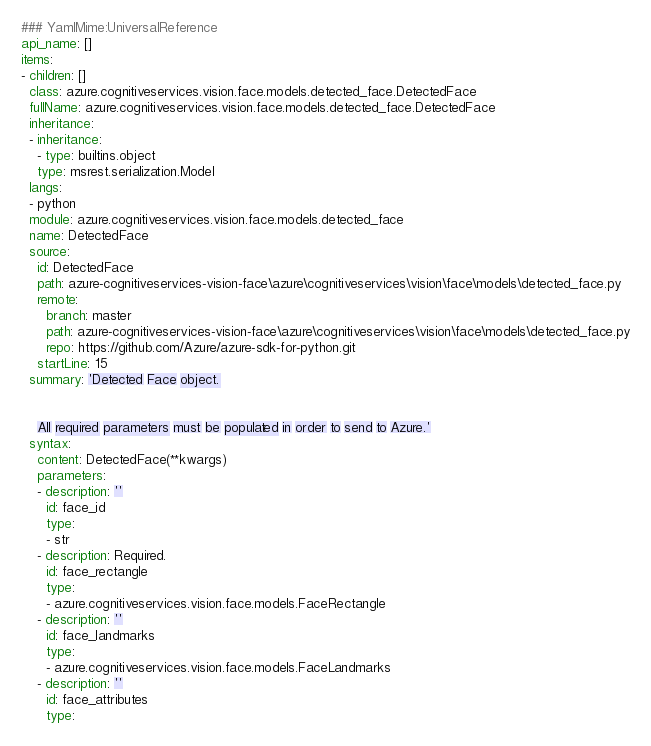<code> <loc_0><loc_0><loc_500><loc_500><_YAML_>### YamlMime:UniversalReference
api_name: []
items:
- children: []
  class: azure.cognitiveservices.vision.face.models.detected_face.DetectedFace
  fullName: azure.cognitiveservices.vision.face.models.detected_face.DetectedFace
  inheritance:
  - inheritance:
    - type: builtins.object
    type: msrest.serialization.Model
  langs:
  - python
  module: azure.cognitiveservices.vision.face.models.detected_face
  name: DetectedFace
  source:
    id: DetectedFace
    path: azure-cognitiveservices-vision-face\azure\cognitiveservices\vision\face\models\detected_face.py
    remote:
      branch: master
      path: azure-cognitiveservices-vision-face\azure\cognitiveservices\vision\face\models\detected_face.py
      repo: https://github.com/Azure/azure-sdk-for-python.git
    startLine: 15
  summary: 'Detected Face object.


    All required parameters must be populated in order to send to Azure.'
  syntax:
    content: DetectedFace(**kwargs)
    parameters:
    - description: ''
      id: face_id
      type:
      - str
    - description: Required.
      id: face_rectangle
      type:
      - azure.cognitiveservices.vision.face.models.FaceRectangle
    - description: ''
      id: face_landmarks
      type:
      - azure.cognitiveservices.vision.face.models.FaceLandmarks
    - description: ''
      id: face_attributes
      type:</code> 